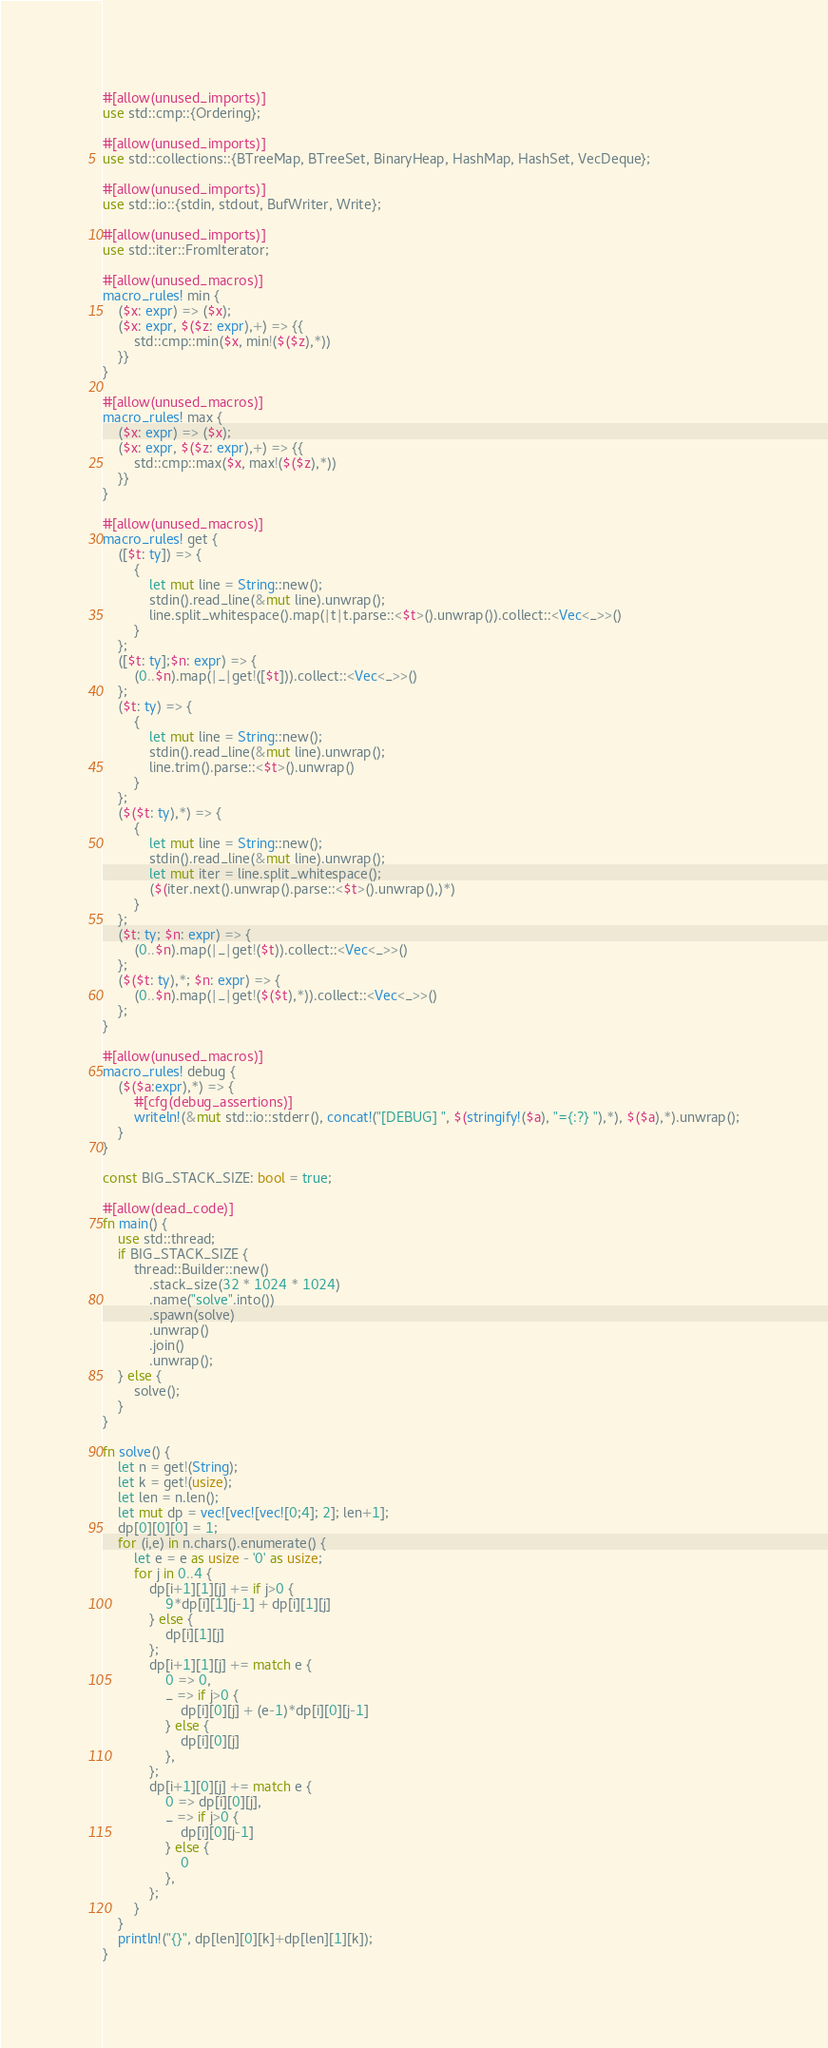<code> <loc_0><loc_0><loc_500><loc_500><_Rust_>#[allow(unused_imports)]
use std::cmp::{Ordering};

#[allow(unused_imports)]
use std::collections::{BTreeMap, BTreeSet, BinaryHeap, HashMap, HashSet, VecDeque};

#[allow(unused_imports)]
use std::io::{stdin, stdout, BufWriter, Write};

#[allow(unused_imports)]
use std::iter::FromIterator;

#[allow(unused_macros)]
macro_rules! min {
    ($x: expr) => ($x);
    ($x: expr, $($z: expr),+) => {{
        std::cmp::min($x, min!($($z),*))
    }}
}

#[allow(unused_macros)]
macro_rules! max {
    ($x: expr) => ($x);
    ($x: expr, $($z: expr),+) => {{
        std::cmp::max($x, max!($($z),*))
    }}
}

#[allow(unused_macros)]
macro_rules! get { 
    ([$t: ty]) => { 
        { 
            let mut line = String::new(); 
            stdin().read_line(&mut line).unwrap(); 
            line.split_whitespace().map(|t|t.parse::<$t>().unwrap()).collect::<Vec<_>>()
        }
    };
    ([$t: ty];$n: expr) => {
        (0..$n).map(|_|get!([$t])).collect::<Vec<_>>()
    };
    ($t: ty) => {
        {
            let mut line = String::new();
            stdin().read_line(&mut line).unwrap();
            line.trim().parse::<$t>().unwrap()
        }
    };
    ($($t: ty),*) => {
        { 
            let mut line = String::new();
            stdin().read_line(&mut line).unwrap();
            let mut iter = line.split_whitespace();
            ($(iter.next().unwrap().parse::<$t>().unwrap(),)*)
        }
    };
    ($t: ty; $n: expr) => {
        (0..$n).map(|_|get!($t)).collect::<Vec<_>>()
    };
    ($($t: ty),*; $n: expr) => {
        (0..$n).map(|_|get!($($t),*)).collect::<Vec<_>>()
    };
}

#[allow(unused_macros)]
macro_rules! debug {
    ($($a:expr),*) => {
        #[cfg(debug_assertions)]
        writeln!(&mut std::io::stderr(), concat!("[DEBUG] ", $(stringify!($a), "={:?} "),*), $($a),*).unwrap();
    }
}

const BIG_STACK_SIZE: bool = true;

#[allow(dead_code)]
fn main() {
    use std::thread;
    if BIG_STACK_SIZE {
        thread::Builder::new()
            .stack_size(32 * 1024 * 1024)
            .name("solve".into())
            .spawn(solve)
            .unwrap()
            .join()
            .unwrap();
    } else {
        solve();
    }
}

fn solve() {
    let n = get!(String);
    let k = get!(usize);
    let len = n.len();
    let mut dp = vec![vec![vec![0;4]; 2]; len+1];
    dp[0][0][0] = 1;
    for (i,e) in n.chars().enumerate() {
        let e = e as usize - '0' as usize;
        for j in 0..4 {
            dp[i+1][1][j] += if j>0 {
                9*dp[i][1][j-1] + dp[i][1][j]
            } else {
                dp[i][1][j]
            };
            dp[i+1][1][j] += match e {
                0 => 0,
                _ => if j>0 {
                    dp[i][0][j] + (e-1)*dp[i][0][j-1]
                } else {
                    dp[i][0][j]
                },
            };
            dp[i+1][0][j] += match e {
                0 => dp[i][0][j],
                _ => if j>0 {
                    dp[i][0][j-1]
                } else {
                    0
                },
            };
        }
    }
    println!("{}", dp[len][0][k]+dp[len][1][k]);
}
</code> 